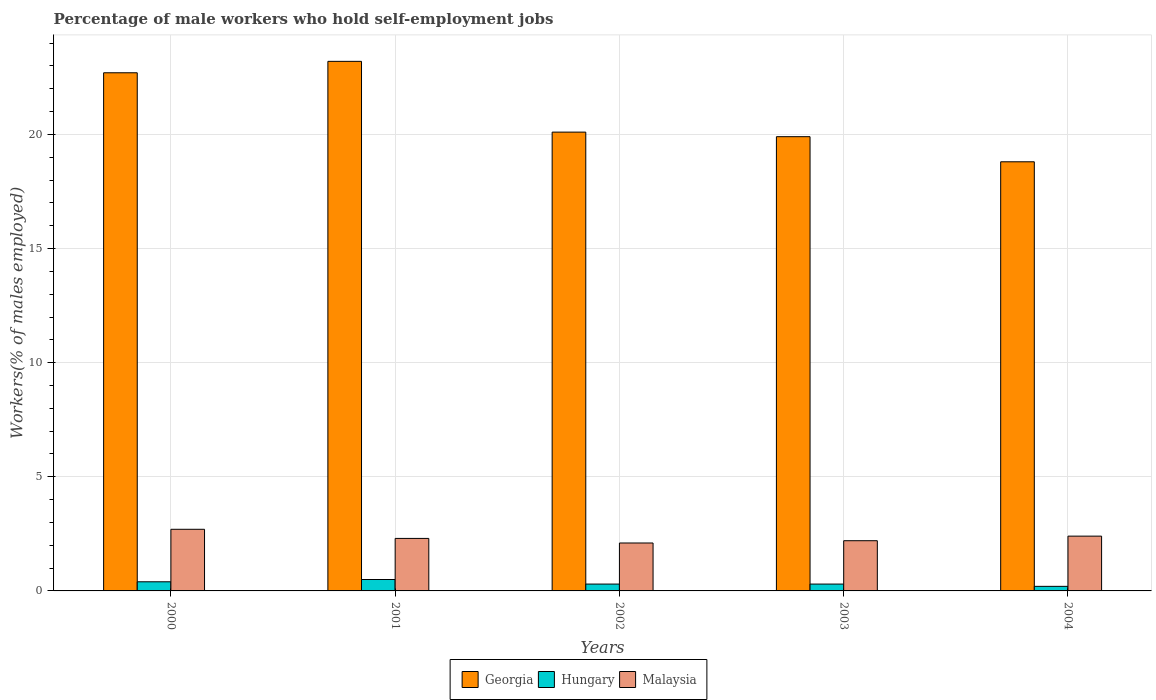In how many cases, is the number of bars for a given year not equal to the number of legend labels?
Your answer should be very brief. 0. What is the percentage of self-employed male workers in Hungary in 2001?
Your response must be concise. 0.5. Across all years, what is the maximum percentage of self-employed male workers in Malaysia?
Offer a terse response. 2.7. Across all years, what is the minimum percentage of self-employed male workers in Malaysia?
Make the answer very short. 2.1. In which year was the percentage of self-employed male workers in Georgia minimum?
Your answer should be compact. 2004. What is the total percentage of self-employed male workers in Malaysia in the graph?
Provide a succinct answer. 11.7. What is the difference between the percentage of self-employed male workers in Malaysia in 2000 and that in 2003?
Your answer should be very brief. 0.5. What is the difference between the percentage of self-employed male workers in Hungary in 2000 and the percentage of self-employed male workers in Malaysia in 2002?
Provide a succinct answer. -1.7. What is the average percentage of self-employed male workers in Georgia per year?
Provide a short and direct response. 20.94. In the year 2004, what is the difference between the percentage of self-employed male workers in Georgia and percentage of self-employed male workers in Hungary?
Ensure brevity in your answer.  18.6. In how many years, is the percentage of self-employed male workers in Georgia greater than 12 %?
Offer a very short reply. 5. Is the percentage of self-employed male workers in Malaysia in 2000 less than that in 2002?
Your answer should be very brief. No. Is the difference between the percentage of self-employed male workers in Georgia in 2000 and 2004 greater than the difference between the percentage of self-employed male workers in Hungary in 2000 and 2004?
Your answer should be very brief. Yes. What is the difference between the highest and the lowest percentage of self-employed male workers in Hungary?
Offer a terse response. 0.3. What does the 2nd bar from the left in 2004 represents?
Keep it short and to the point. Hungary. What does the 3rd bar from the right in 2002 represents?
Provide a short and direct response. Georgia. Is it the case that in every year, the sum of the percentage of self-employed male workers in Georgia and percentage of self-employed male workers in Malaysia is greater than the percentage of self-employed male workers in Hungary?
Your answer should be very brief. Yes. Are all the bars in the graph horizontal?
Your response must be concise. No. How many years are there in the graph?
Make the answer very short. 5. Does the graph contain any zero values?
Give a very brief answer. No. Does the graph contain grids?
Your answer should be very brief. Yes. Where does the legend appear in the graph?
Ensure brevity in your answer.  Bottom center. What is the title of the graph?
Your answer should be very brief. Percentage of male workers who hold self-employment jobs. What is the label or title of the Y-axis?
Offer a very short reply. Workers(% of males employed). What is the Workers(% of males employed) in Georgia in 2000?
Your answer should be very brief. 22.7. What is the Workers(% of males employed) of Hungary in 2000?
Your response must be concise. 0.4. What is the Workers(% of males employed) of Malaysia in 2000?
Offer a terse response. 2.7. What is the Workers(% of males employed) in Georgia in 2001?
Your answer should be compact. 23.2. What is the Workers(% of males employed) of Hungary in 2001?
Provide a succinct answer. 0.5. What is the Workers(% of males employed) of Malaysia in 2001?
Give a very brief answer. 2.3. What is the Workers(% of males employed) of Georgia in 2002?
Offer a terse response. 20.1. What is the Workers(% of males employed) in Hungary in 2002?
Ensure brevity in your answer.  0.3. What is the Workers(% of males employed) of Malaysia in 2002?
Give a very brief answer. 2.1. What is the Workers(% of males employed) in Georgia in 2003?
Provide a succinct answer. 19.9. What is the Workers(% of males employed) of Hungary in 2003?
Keep it short and to the point. 0.3. What is the Workers(% of males employed) of Malaysia in 2003?
Your answer should be very brief. 2.2. What is the Workers(% of males employed) in Georgia in 2004?
Provide a short and direct response. 18.8. What is the Workers(% of males employed) in Hungary in 2004?
Offer a terse response. 0.2. What is the Workers(% of males employed) of Malaysia in 2004?
Ensure brevity in your answer.  2.4. Across all years, what is the maximum Workers(% of males employed) in Georgia?
Ensure brevity in your answer.  23.2. Across all years, what is the maximum Workers(% of males employed) in Hungary?
Ensure brevity in your answer.  0.5. Across all years, what is the maximum Workers(% of males employed) of Malaysia?
Provide a short and direct response. 2.7. Across all years, what is the minimum Workers(% of males employed) of Georgia?
Offer a terse response. 18.8. Across all years, what is the minimum Workers(% of males employed) of Hungary?
Your answer should be very brief. 0.2. Across all years, what is the minimum Workers(% of males employed) in Malaysia?
Your response must be concise. 2.1. What is the total Workers(% of males employed) of Georgia in the graph?
Offer a very short reply. 104.7. What is the difference between the Workers(% of males employed) in Hungary in 2000 and that in 2001?
Ensure brevity in your answer.  -0.1. What is the difference between the Workers(% of males employed) in Malaysia in 2000 and that in 2001?
Offer a terse response. 0.4. What is the difference between the Workers(% of males employed) in Malaysia in 2000 and that in 2002?
Provide a short and direct response. 0.6. What is the difference between the Workers(% of males employed) of Georgia in 2000 and that in 2003?
Your answer should be compact. 2.8. What is the difference between the Workers(% of males employed) in Georgia in 2000 and that in 2004?
Provide a succinct answer. 3.9. What is the difference between the Workers(% of males employed) in Georgia in 2001 and that in 2002?
Keep it short and to the point. 3.1. What is the difference between the Workers(% of males employed) in Hungary in 2001 and that in 2002?
Your response must be concise. 0.2. What is the difference between the Workers(% of males employed) in Malaysia in 2001 and that in 2002?
Your response must be concise. 0.2. What is the difference between the Workers(% of males employed) of Hungary in 2001 and that in 2003?
Give a very brief answer. 0.2. What is the difference between the Workers(% of males employed) in Malaysia in 2001 and that in 2003?
Your answer should be very brief. 0.1. What is the difference between the Workers(% of males employed) in Hungary in 2001 and that in 2004?
Offer a terse response. 0.3. What is the difference between the Workers(% of males employed) in Malaysia in 2001 and that in 2004?
Keep it short and to the point. -0.1. What is the difference between the Workers(% of males employed) of Georgia in 2002 and that in 2004?
Keep it short and to the point. 1.3. What is the difference between the Workers(% of males employed) of Hungary in 2002 and that in 2004?
Your answer should be compact. 0.1. What is the difference between the Workers(% of males employed) of Malaysia in 2002 and that in 2004?
Your response must be concise. -0.3. What is the difference between the Workers(% of males employed) in Hungary in 2003 and that in 2004?
Make the answer very short. 0.1. What is the difference between the Workers(% of males employed) of Malaysia in 2003 and that in 2004?
Make the answer very short. -0.2. What is the difference between the Workers(% of males employed) of Georgia in 2000 and the Workers(% of males employed) of Hungary in 2001?
Offer a very short reply. 22.2. What is the difference between the Workers(% of males employed) in Georgia in 2000 and the Workers(% of males employed) in Malaysia in 2001?
Keep it short and to the point. 20.4. What is the difference between the Workers(% of males employed) in Georgia in 2000 and the Workers(% of males employed) in Hungary in 2002?
Offer a terse response. 22.4. What is the difference between the Workers(% of males employed) in Georgia in 2000 and the Workers(% of males employed) in Malaysia in 2002?
Provide a short and direct response. 20.6. What is the difference between the Workers(% of males employed) in Hungary in 2000 and the Workers(% of males employed) in Malaysia in 2002?
Your response must be concise. -1.7. What is the difference between the Workers(% of males employed) of Georgia in 2000 and the Workers(% of males employed) of Hungary in 2003?
Your answer should be very brief. 22.4. What is the difference between the Workers(% of males employed) in Georgia in 2000 and the Workers(% of males employed) in Malaysia in 2004?
Your answer should be compact. 20.3. What is the difference between the Workers(% of males employed) of Georgia in 2001 and the Workers(% of males employed) of Hungary in 2002?
Make the answer very short. 22.9. What is the difference between the Workers(% of males employed) of Georgia in 2001 and the Workers(% of males employed) of Malaysia in 2002?
Make the answer very short. 21.1. What is the difference between the Workers(% of males employed) in Georgia in 2001 and the Workers(% of males employed) in Hungary in 2003?
Offer a very short reply. 22.9. What is the difference between the Workers(% of males employed) of Georgia in 2001 and the Workers(% of males employed) of Malaysia in 2003?
Your response must be concise. 21. What is the difference between the Workers(% of males employed) in Georgia in 2001 and the Workers(% of males employed) in Hungary in 2004?
Offer a very short reply. 23. What is the difference between the Workers(% of males employed) of Georgia in 2001 and the Workers(% of males employed) of Malaysia in 2004?
Provide a short and direct response. 20.8. What is the difference between the Workers(% of males employed) in Georgia in 2002 and the Workers(% of males employed) in Hungary in 2003?
Provide a short and direct response. 19.8. What is the difference between the Workers(% of males employed) in Georgia in 2002 and the Workers(% of males employed) in Malaysia in 2003?
Your answer should be very brief. 17.9. What is the difference between the Workers(% of males employed) in Hungary in 2002 and the Workers(% of males employed) in Malaysia in 2003?
Give a very brief answer. -1.9. What is the difference between the Workers(% of males employed) in Georgia in 2002 and the Workers(% of males employed) in Malaysia in 2004?
Offer a very short reply. 17.7. What is the difference between the Workers(% of males employed) in Hungary in 2002 and the Workers(% of males employed) in Malaysia in 2004?
Keep it short and to the point. -2.1. What is the difference between the Workers(% of males employed) in Georgia in 2003 and the Workers(% of males employed) in Hungary in 2004?
Make the answer very short. 19.7. What is the difference between the Workers(% of males employed) in Georgia in 2003 and the Workers(% of males employed) in Malaysia in 2004?
Provide a succinct answer. 17.5. What is the difference between the Workers(% of males employed) in Hungary in 2003 and the Workers(% of males employed) in Malaysia in 2004?
Your answer should be compact. -2.1. What is the average Workers(% of males employed) of Georgia per year?
Make the answer very short. 20.94. What is the average Workers(% of males employed) in Hungary per year?
Your answer should be very brief. 0.34. What is the average Workers(% of males employed) in Malaysia per year?
Give a very brief answer. 2.34. In the year 2000, what is the difference between the Workers(% of males employed) in Georgia and Workers(% of males employed) in Hungary?
Offer a terse response. 22.3. In the year 2001, what is the difference between the Workers(% of males employed) of Georgia and Workers(% of males employed) of Hungary?
Offer a very short reply. 22.7. In the year 2001, what is the difference between the Workers(% of males employed) of Georgia and Workers(% of males employed) of Malaysia?
Offer a terse response. 20.9. In the year 2002, what is the difference between the Workers(% of males employed) of Georgia and Workers(% of males employed) of Hungary?
Provide a short and direct response. 19.8. In the year 2002, what is the difference between the Workers(% of males employed) in Georgia and Workers(% of males employed) in Malaysia?
Your answer should be very brief. 18. In the year 2003, what is the difference between the Workers(% of males employed) of Georgia and Workers(% of males employed) of Hungary?
Your answer should be very brief. 19.6. In the year 2003, what is the difference between the Workers(% of males employed) in Hungary and Workers(% of males employed) in Malaysia?
Your answer should be compact. -1.9. In the year 2004, what is the difference between the Workers(% of males employed) of Georgia and Workers(% of males employed) of Malaysia?
Make the answer very short. 16.4. What is the ratio of the Workers(% of males employed) of Georgia in 2000 to that in 2001?
Your answer should be very brief. 0.98. What is the ratio of the Workers(% of males employed) of Malaysia in 2000 to that in 2001?
Keep it short and to the point. 1.17. What is the ratio of the Workers(% of males employed) of Georgia in 2000 to that in 2002?
Provide a succinct answer. 1.13. What is the ratio of the Workers(% of males employed) of Georgia in 2000 to that in 2003?
Provide a succinct answer. 1.14. What is the ratio of the Workers(% of males employed) of Hungary in 2000 to that in 2003?
Offer a terse response. 1.33. What is the ratio of the Workers(% of males employed) in Malaysia in 2000 to that in 2003?
Offer a very short reply. 1.23. What is the ratio of the Workers(% of males employed) in Georgia in 2000 to that in 2004?
Give a very brief answer. 1.21. What is the ratio of the Workers(% of males employed) in Hungary in 2000 to that in 2004?
Keep it short and to the point. 2. What is the ratio of the Workers(% of males employed) of Malaysia in 2000 to that in 2004?
Give a very brief answer. 1.12. What is the ratio of the Workers(% of males employed) in Georgia in 2001 to that in 2002?
Provide a succinct answer. 1.15. What is the ratio of the Workers(% of males employed) in Hungary in 2001 to that in 2002?
Keep it short and to the point. 1.67. What is the ratio of the Workers(% of males employed) in Malaysia in 2001 to that in 2002?
Offer a terse response. 1.1. What is the ratio of the Workers(% of males employed) of Georgia in 2001 to that in 2003?
Ensure brevity in your answer.  1.17. What is the ratio of the Workers(% of males employed) in Malaysia in 2001 to that in 2003?
Give a very brief answer. 1.05. What is the ratio of the Workers(% of males employed) of Georgia in 2001 to that in 2004?
Offer a terse response. 1.23. What is the ratio of the Workers(% of males employed) in Georgia in 2002 to that in 2003?
Provide a short and direct response. 1.01. What is the ratio of the Workers(% of males employed) in Hungary in 2002 to that in 2003?
Make the answer very short. 1. What is the ratio of the Workers(% of males employed) of Malaysia in 2002 to that in 2003?
Provide a succinct answer. 0.95. What is the ratio of the Workers(% of males employed) in Georgia in 2002 to that in 2004?
Give a very brief answer. 1.07. What is the ratio of the Workers(% of males employed) of Hungary in 2002 to that in 2004?
Give a very brief answer. 1.5. What is the ratio of the Workers(% of males employed) in Malaysia in 2002 to that in 2004?
Provide a short and direct response. 0.88. What is the ratio of the Workers(% of males employed) of Georgia in 2003 to that in 2004?
Offer a very short reply. 1.06. What is the ratio of the Workers(% of males employed) of Malaysia in 2003 to that in 2004?
Provide a short and direct response. 0.92. What is the difference between the highest and the second highest Workers(% of males employed) of Hungary?
Offer a terse response. 0.1. What is the difference between the highest and the second highest Workers(% of males employed) of Malaysia?
Keep it short and to the point. 0.3. What is the difference between the highest and the lowest Workers(% of males employed) in Malaysia?
Keep it short and to the point. 0.6. 